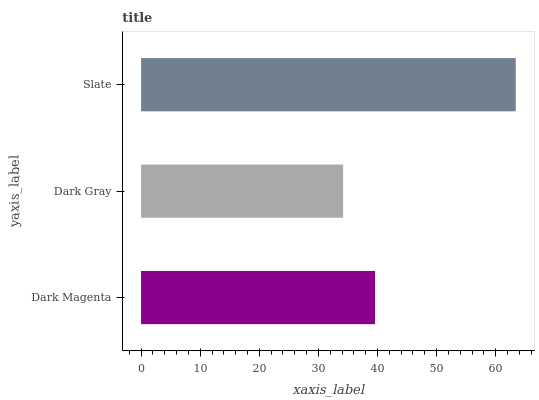Is Dark Gray the minimum?
Answer yes or no. Yes. Is Slate the maximum?
Answer yes or no. Yes. Is Slate the minimum?
Answer yes or no. No. Is Dark Gray the maximum?
Answer yes or no. No. Is Slate greater than Dark Gray?
Answer yes or no. Yes. Is Dark Gray less than Slate?
Answer yes or no. Yes. Is Dark Gray greater than Slate?
Answer yes or no. No. Is Slate less than Dark Gray?
Answer yes or no. No. Is Dark Magenta the high median?
Answer yes or no. Yes. Is Dark Magenta the low median?
Answer yes or no. Yes. Is Dark Gray the high median?
Answer yes or no. No. Is Slate the low median?
Answer yes or no. No. 